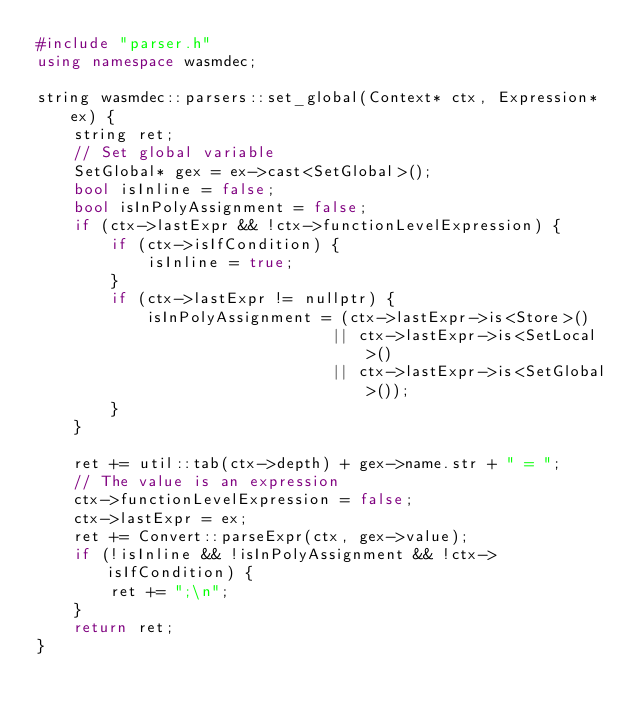Convert code to text. <code><loc_0><loc_0><loc_500><loc_500><_C++_>#include "parser.h"
using namespace wasmdec;

string wasmdec::parsers::set_global(Context* ctx, Expression* ex) {
    string ret;
    // Set global variable
    SetGlobal* gex = ex->cast<SetGlobal>();
    bool isInline = false;
    bool isInPolyAssignment = false;
    if (ctx->lastExpr && !ctx->functionLevelExpression) {
        if (ctx->isIfCondition) {
            isInline = true;
        }
        if (ctx->lastExpr != nullptr) {
            isInPolyAssignment = (ctx->lastExpr->is<Store>()
                                || ctx->lastExpr->is<SetLocal>()
                                || ctx->lastExpr->is<SetGlobal>());
        }
    }

    ret += util::tab(ctx->depth) + gex->name.str + " = ";
    // The value is an expression
    ctx->functionLevelExpression = false;
    ctx->lastExpr = ex;
    ret += Convert::parseExpr(ctx, gex->value);
    if (!isInline && !isInPolyAssignment && !ctx->isIfCondition) {
        ret += ";\n";
    }
    return ret;
}</code> 